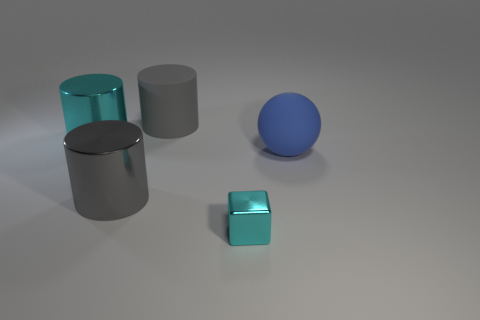Is the number of big shiny objects greater than the number of cyan metal blocks?
Your answer should be very brief. Yes. What number of other things are the same color as the matte cylinder?
Ensure brevity in your answer.  1. There is a cyan metallic thing that is in front of the gray shiny thing; how many blue rubber balls are to the right of it?
Provide a short and direct response. 1. There is a large cyan metal cylinder; are there any big gray shiny objects in front of it?
Make the answer very short. Yes. There is a large gray thing behind the cyan metal object to the left of the tiny object; what is its shape?
Keep it short and to the point. Cylinder. Is the number of big blue rubber objects left of the large cyan thing less than the number of metal objects that are left of the tiny cyan shiny object?
Provide a short and direct response. Yes. What is the color of the other large matte thing that is the same shape as the big cyan thing?
Offer a very short reply. Gray. What number of cyan shiny objects are both left of the matte cylinder and right of the big cyan object?
Give a very brief answer. 0. Is the number of tiny cyan things that are to the left of the cube greater than the number of big cylinders to the right of the large cyan object?
Your answer should be very brief. No. The gray matte object is what size?
Your response must be concise. Large. 